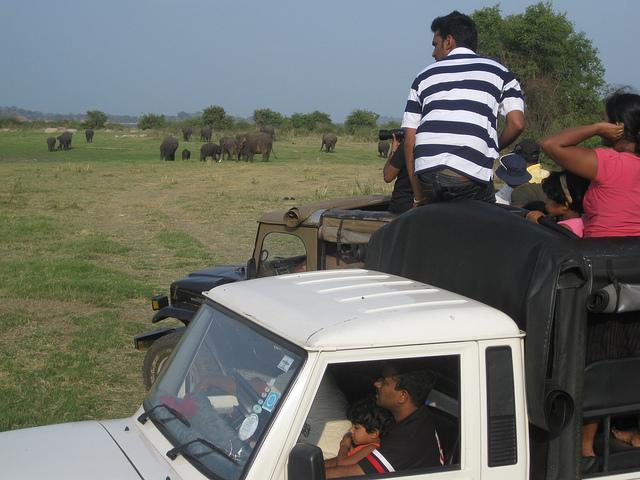Is this a zoo?
Answer briefly. No. Do they have guns?
Concise answer only. No. Are these tourists at a game preserve?
Keep it brief. Yes. 